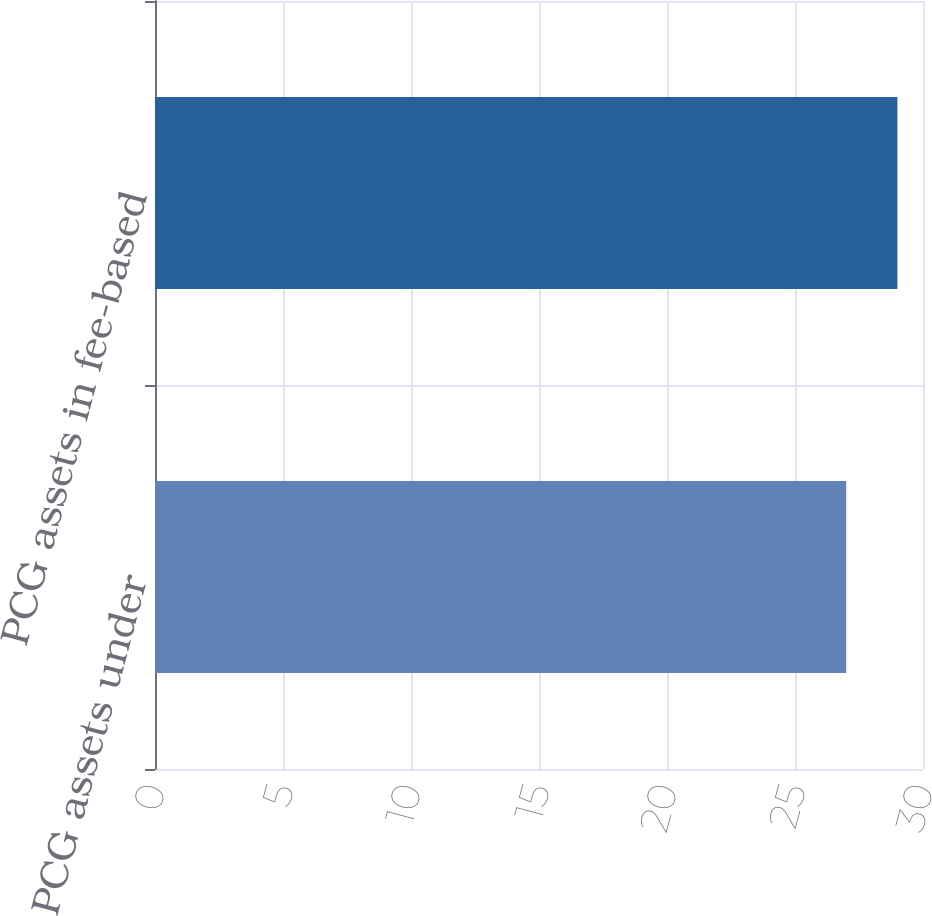Convert chart. <chart><loc_0><loc_0><loc_500><loc_500><bar_chart><fcel>PCG assets under<fcel>PCG assets in fee-based<nl><fcel>27<fcel>29<nl></chart> 